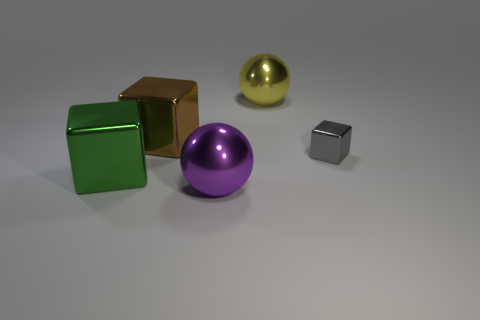Is there any other thing that is the same size as the gray shiny object?
Provide a short and direct response. No. There is another purple object that is the same material as the small thing; what size is it?
Your answer should be very brief. Large. Are there more large yellow spheres right of the purple thing than large purple shiny objects that are right of the gray block?
Your response must be concise. Yes. Are there any other purple things that have the same shape as the tiny object?
Your answer should be very brief. No. There is a metallic sphere that is in front of the yellow metal sphere; is it the same size as the big brown metal cube?
Ensure brevity in your answer.  Yes. Are any big gray things visible?
Offer a terse response. No. What number of objects are big balls in front of the tiny gray metal block or purple metallic spheres?
Keep it short and to the point. 1. Is there a brown metallic thing of the same size as the purple metal object?
Your response must be concise. Yes. The yellow thing that is the same material as the purple object is what shape?
Offer a terse response. Sphere. There is a ball behind the large purple metal object; what is its size?
Your response must be concise. Large. 